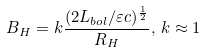Convert formula to latex. <formula><loc_0><loc_0><loc_500><loc_500>B _ { H } = k \frac { ( 2 L _ { b o l } / \varepsilon c ) ^ { \frac { 1 } { 2 } } } { R _ { H } } , \, k \approx 1</formula> 